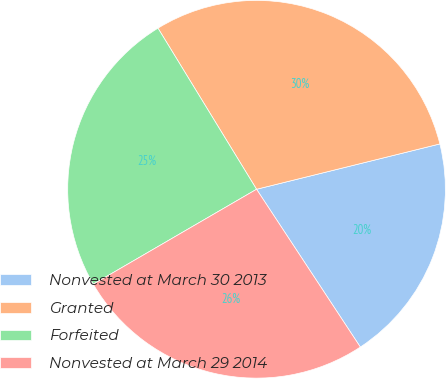Convert chart. <chart><loc_0><loc_0><loc_500><loc_500><pie_chart><fcel>Nonvested at March 30 2013<fcel>Granted<fcel>Forfeited<fcel>Nonvested at March 29 2014<nl><fcel>19.6%<fcel>29.88%<fcel>24.64%<fcel>25.88%<nl></chart> 